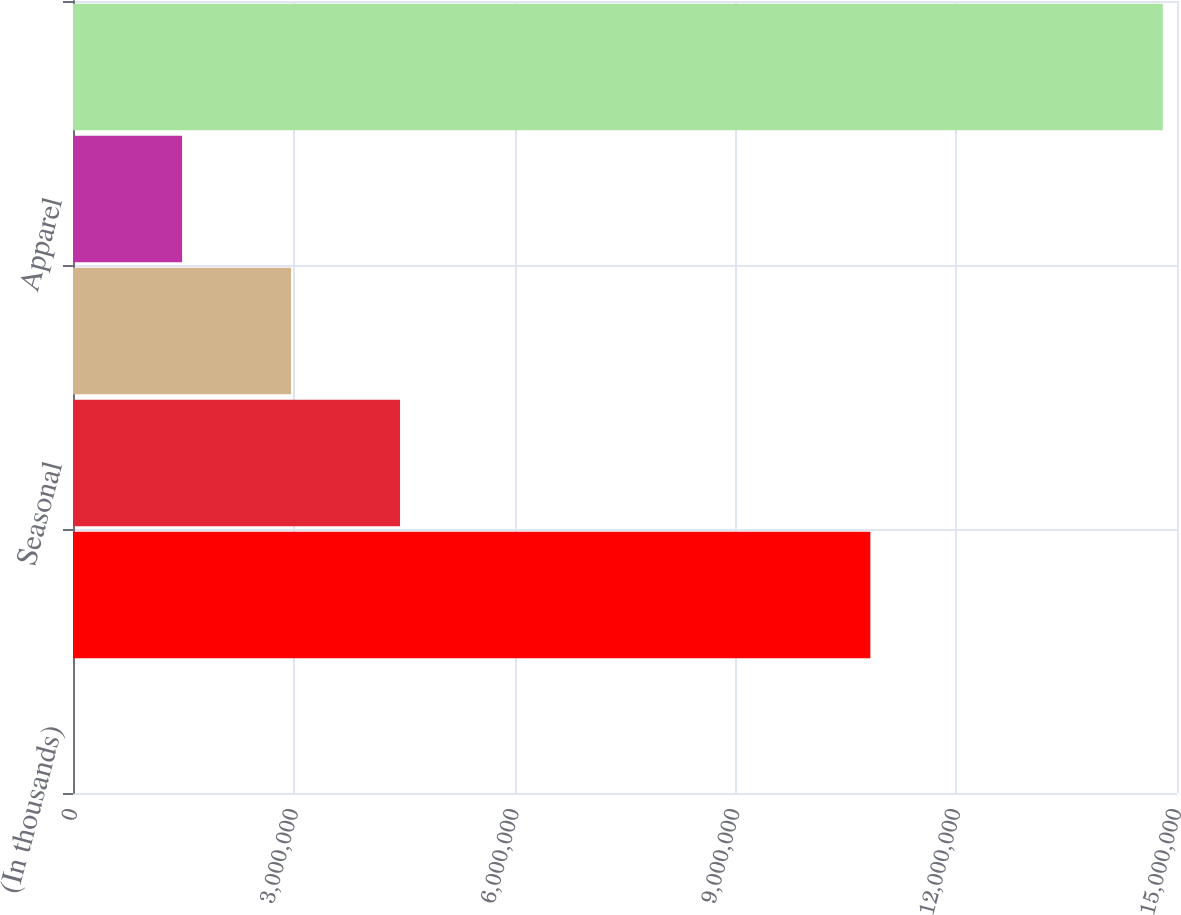Convert chart to OTSL. <chart><loc_0><loc_0><loc_500><loc_500><bar_chart><fcel>(In thousands)<fcel>Consumables<fcel>Seasonal<fcel>Home products<fcel>Apparel<fcel>Net sales<nl><fcel>2011<fcel>1.08337e+07<fcel>4.44356e+06<fcel>2.96305e+06<fcel>1.48253e+06<fcel>1.48072e+07<nl></chart> 